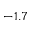<formula> <loc_0><loc_0><loc_500><loc_500>- 1 . 7</formula> 